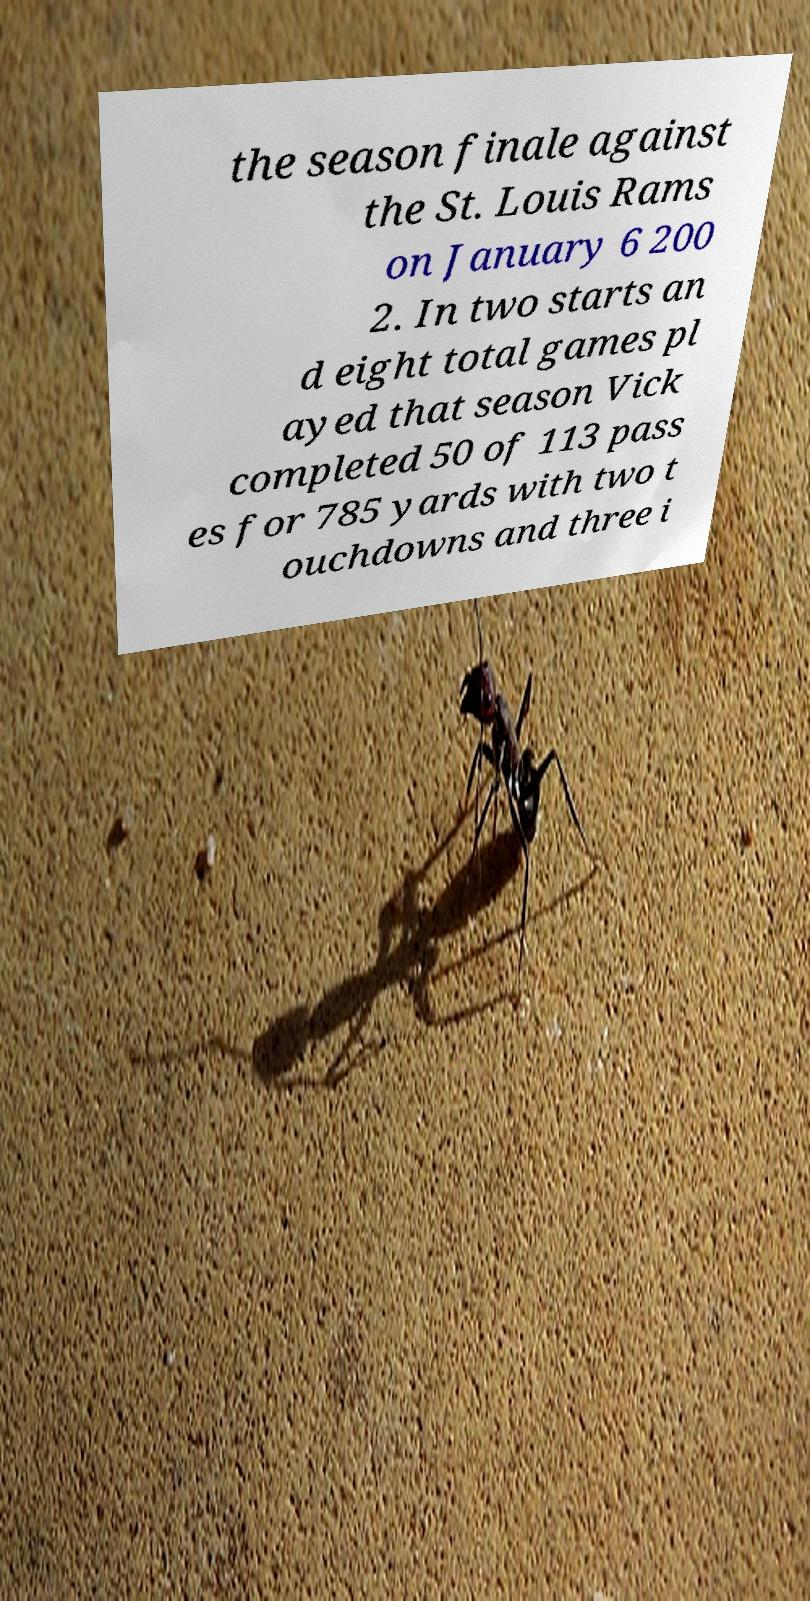Please identify and transcribe the text found in this image. the season finale against the St. Louis Rams on January 6 200 2. In two starts an d eight total games pl ayed that season Vick completed 50 of 113 pass es for 785 yards with two t ouchdowns and three i 